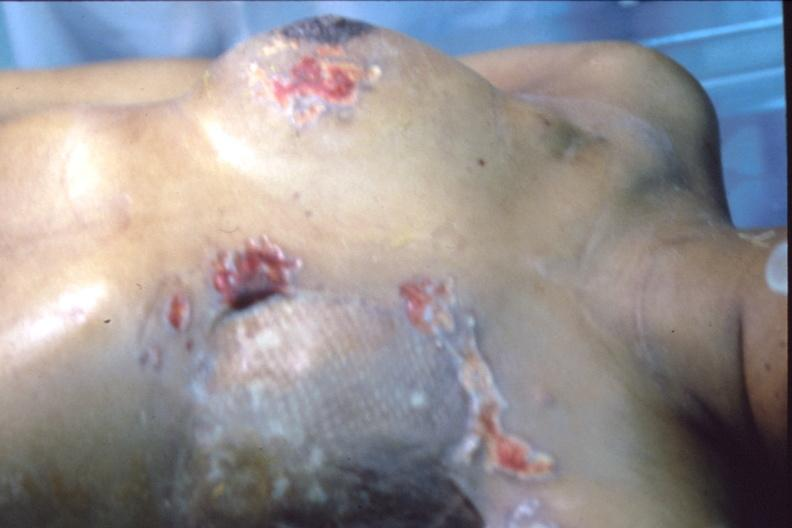what is present?
Answer the question using a single word or phrase. Breast 